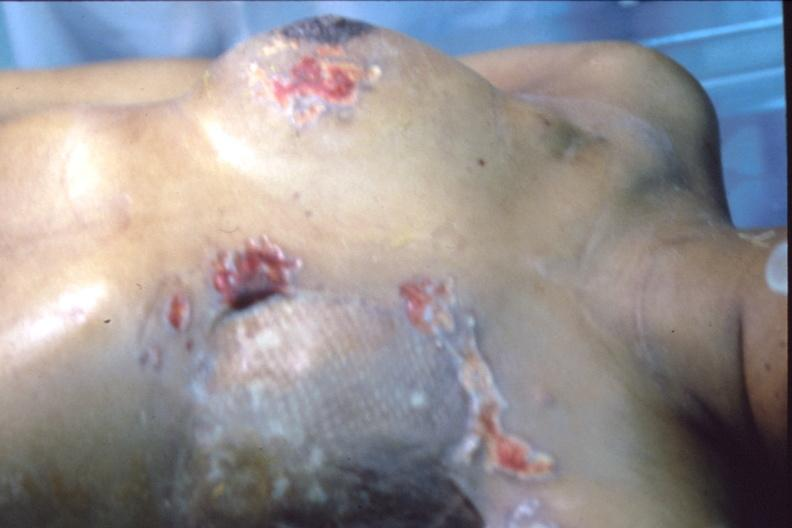what is present?
Answer the question using a single word or phrase. Breast 